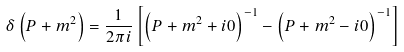Convert formula to latex. <formula><loc_0><loc_0><loc_500><loc_500>\delta \left ( P + m ^ { 2 } \right ) = \frac { 1 } { 2 \pi i } \left [ \left ( P + m ^ { 2 } + i 0 \right ) ^ { - 1 } - \left ( P + m ^ { 2 } - i 0 \right ) ^ { - 1 } \right ]</formula> 